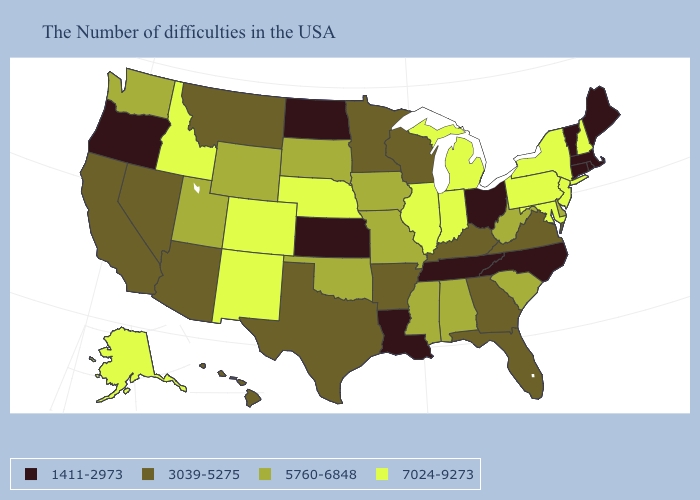What is the value of Montana?
Be succinct. 3039-5275. What is the highest value in the USA?
Write a very short answer. 7024-9273. Does Pennsylvania have the lowest value in the Northeast?
Be succinct. No. What is the value of Connecticut?
Quick response, please. 1411-2973. What is the value of Wyoming?
Give a very brief answer. 5760-6848. What is the highest value in states that border Illinois?
Short answer required. 7024-9273. Name the states that have a value in the range 5760-6848?
Answer briefly. Delaware, South Carolina, West Virginia, Alabama, Mississippi, Missouri, Iowa, Oklahoma, South Dakota, Wyoming, Utah, Washington. What is the highest value in the South ?
Give a very brief answer. 7024-9273. What is the highest value in the Northeast ?
Give a very brief answer. 7024-9273. Name the states that have a value in the range 7024-9273?
Give a very brief answer. New Hampshire, New York, New Jersey, Maryland, Pennsylvania, Michigan, Indiana, Illinois, Nebraska, Colorado, New Mexico, Idaho, Alaska. Does the map have missing data?
Quick response, please. No. What is the value of Arkansas?
Quick response, please. 3039-5275. Which states have the lowest value in the MidWest?
Give a very brief answer. Ohio, Kansas, North Dakota. What is the highest value in the West ?
Give a very brief answer. 7024-9273. Does Vermont have the highest value in the Northeast?
Keep it brief. No. 